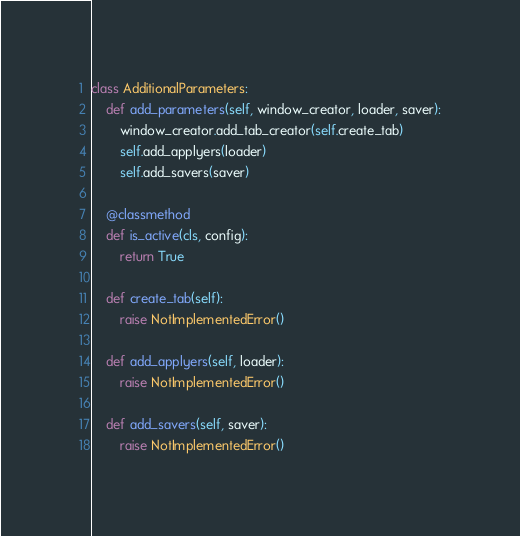Convert code to text. <code><loc_0><loc_0><loc_500><loc_500><_Python_>class AdditionalParameters:
    def add_parameters(self, window_creator, loader, saver):
        window_creator.add_tab_creator(self.create_tab)
        self.add_applyers(loader)
        self.add_savers(saver)
    
    @classmethod
    def is_active(cls, config):
        return True
    
    def create_tab(self):
        raise NotImplementedError()
    
    def add_applyers(self, loader):
        raise NotImplementedError()

    def add_savers(self, saver):
        raise NotImplementedError()</code> 